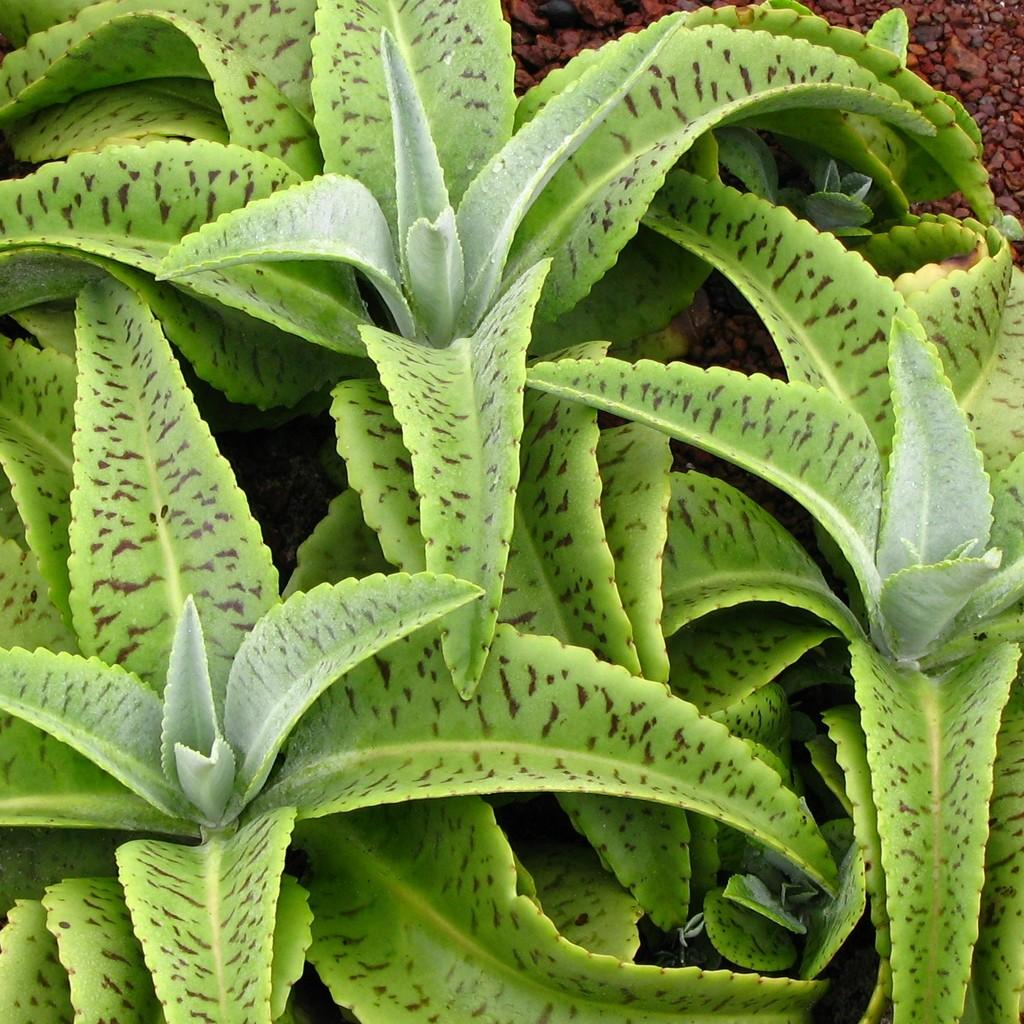What type of living organisms can be seen in the image? Plants can be seen in the image. What type of inanimate objects are present in the image? There are stones towards the top of the image. How does the stomach of the plant appear in the image? There is no visible representation of a plant's stomach in the image, as plants do not have stomachs. 